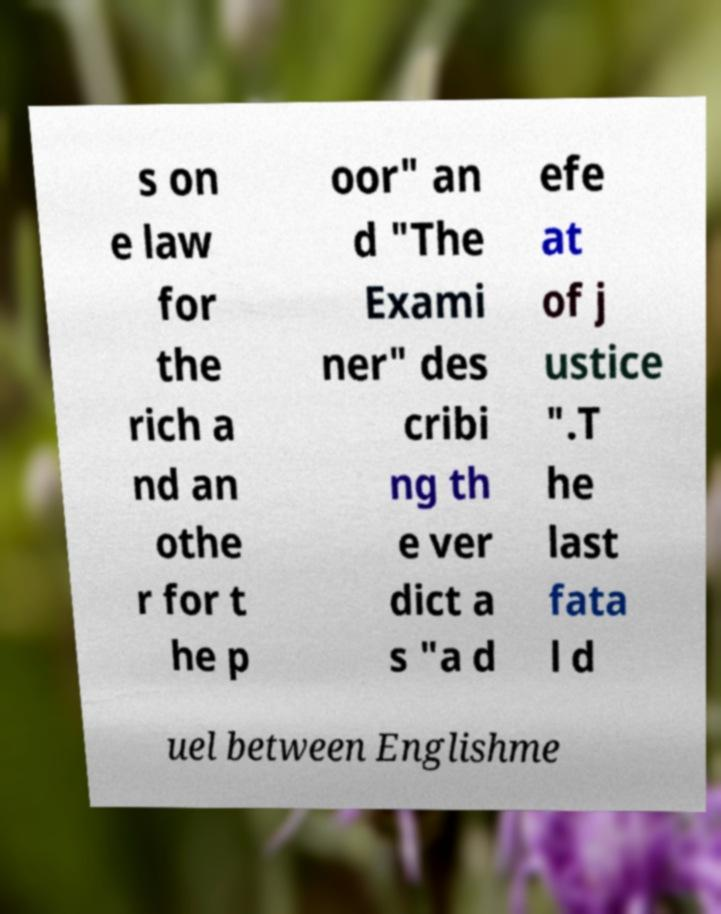There's text embedded in this image that I need extracted. Can you transcribe it verbatim? s on e law for the rich a nd an othe r for t he p oor" an d "The Exami ner" des cribi ng th e ver dict a s "a d efe at of j ustice ".T he last fata l d uel between Englishme 